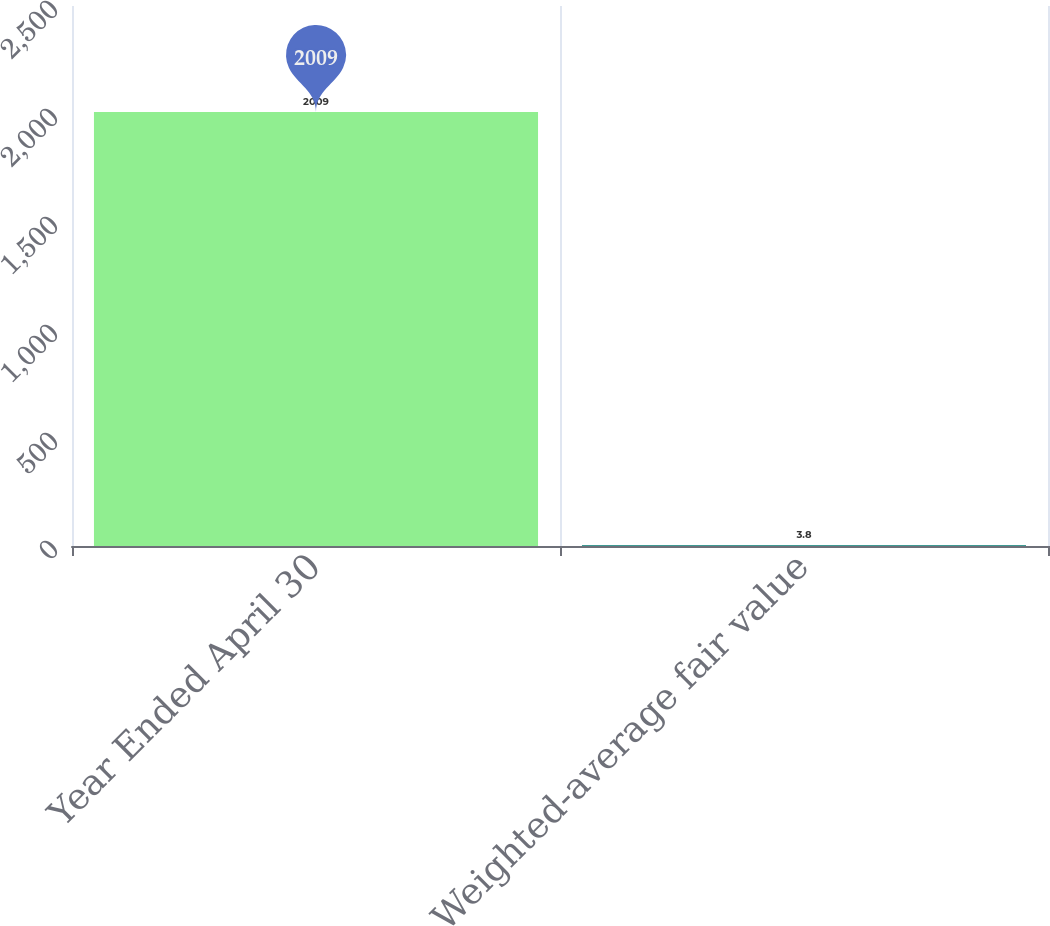Convert chart. <chart><loc_0><loc_0><loc_500><loc_500><bar_chart><fcel>Year Ended April 30<fcel>Weighted-average fair value<nl><fcel>2009<fcel>3.8<nl></chart> 